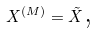Convert formula to latex. <formula><loc_0><loc_0><loc_500><loc_500>X ^ { ( M ) } = \tilde { X } \text {,}</formula> 